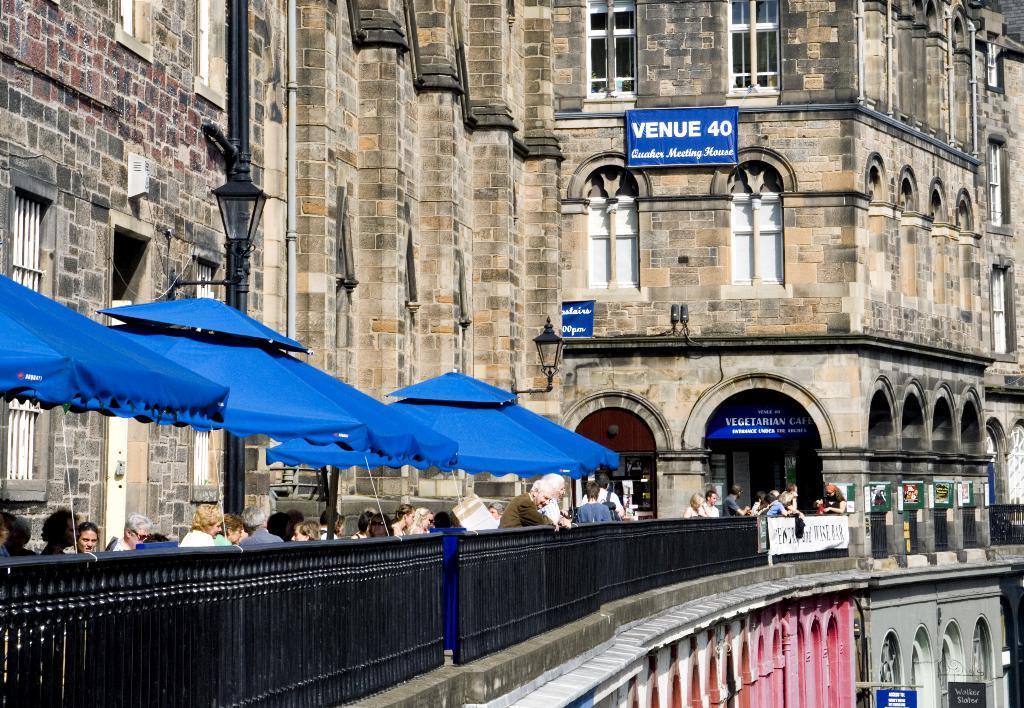Can you describe this image briefly? In this image I can see the group of people with different color dresses. I can see few people are under the blue color tint. To the side there is a railing. In the background there is a light pole and blue color boards to the building. 